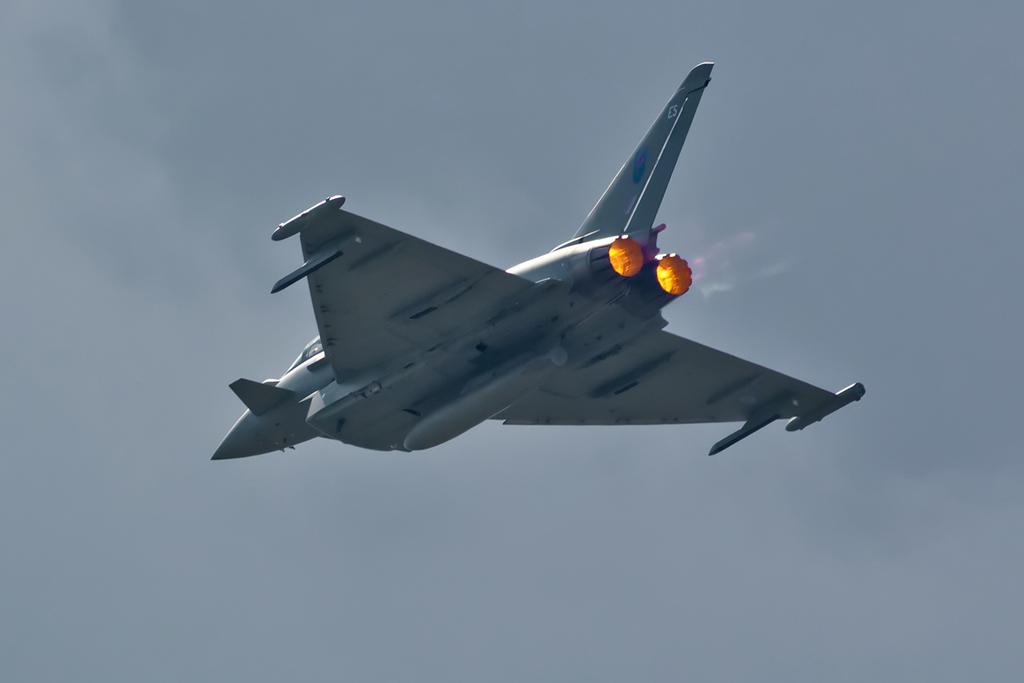What can be seen in the background of the image? There is a sky in the image. What is the main subject of the image? There is a jet plane in the image. Where is the duck swimming in the image? There is no duck present in the image. What type of farm equipment can be seen in the image? There is no farm equipment, such as a plough, present in the image. 